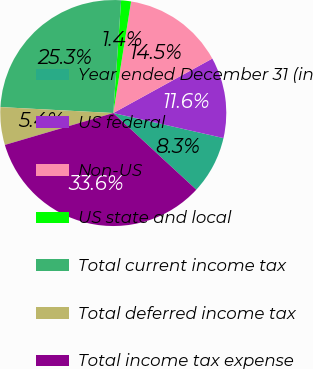<chart> <loc_0><loc_0><loc_500><loc_500><pie_chart><fcel>Year ended December 31 (in<fcel>US federal<fcel>Non-US<fcel>US state and local<fcel>Total current income tax<fcel>Total deferred income tax<fcel>Total income tax expense<nl><fcel>8.31%<fcel>11.56%<fcel>14.48%<fcel>1.41%<fcel>25.27%<fcel>5.39%<fcel>33.58%<nl></chart> 